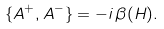Convert formula to latex. <formula><loc_0><loc_0><loc_500><loc_500>\{ A ^ { + } , A ^ { - } \} = - i \, \beta ( H ) .</formula> 